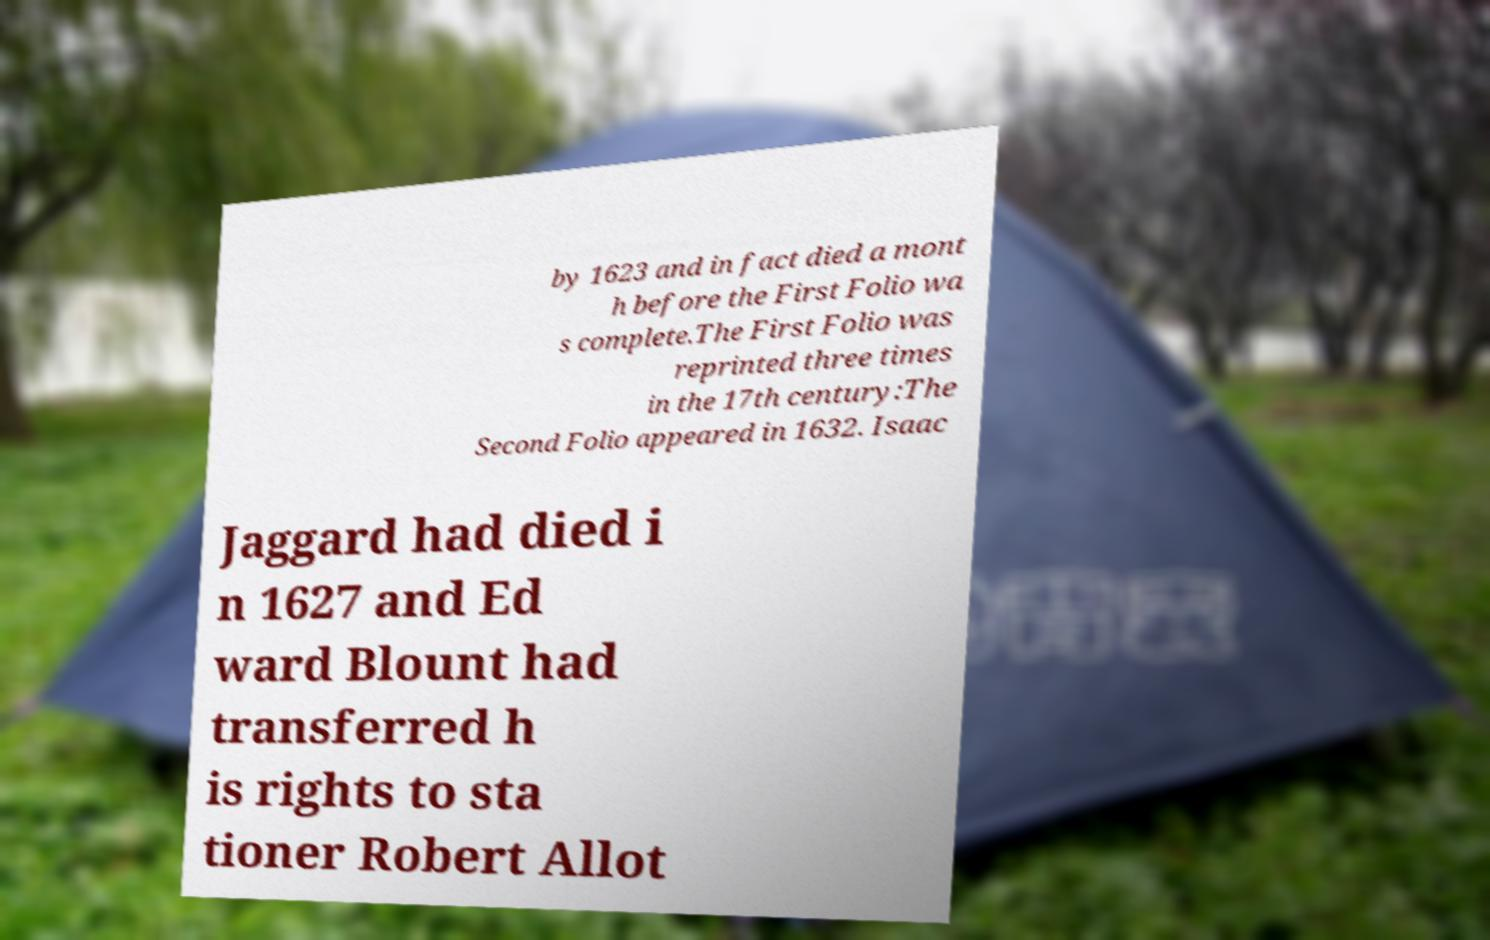What messages or text are displayed in this image? I need them in a readable, typed format. by 1623 and in fact died a mont h before the First Folio wa s complete.The First Folio was reprinted three times in the 17th century:The Second Folio appeared in 1632. Isaac Jaggard had died i n 1627 and Ed ward Blount had transferred h is rights to sta tioner Robert Allot 